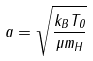<formula> <loc_0><loc_0><loc_500><loc_500>a = \sqrt { \frac { k _ { B } T _ { 0 } } { \mu m _ { H } } }</formula> 